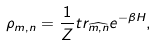<formula> <loc_0><loc_0><loc_500><loc_500>\rho _ { m , n } = \frac { 1 } { Z } t r _ { \widehat { m , n } } e ^ { - \beta H } ,</formula> 